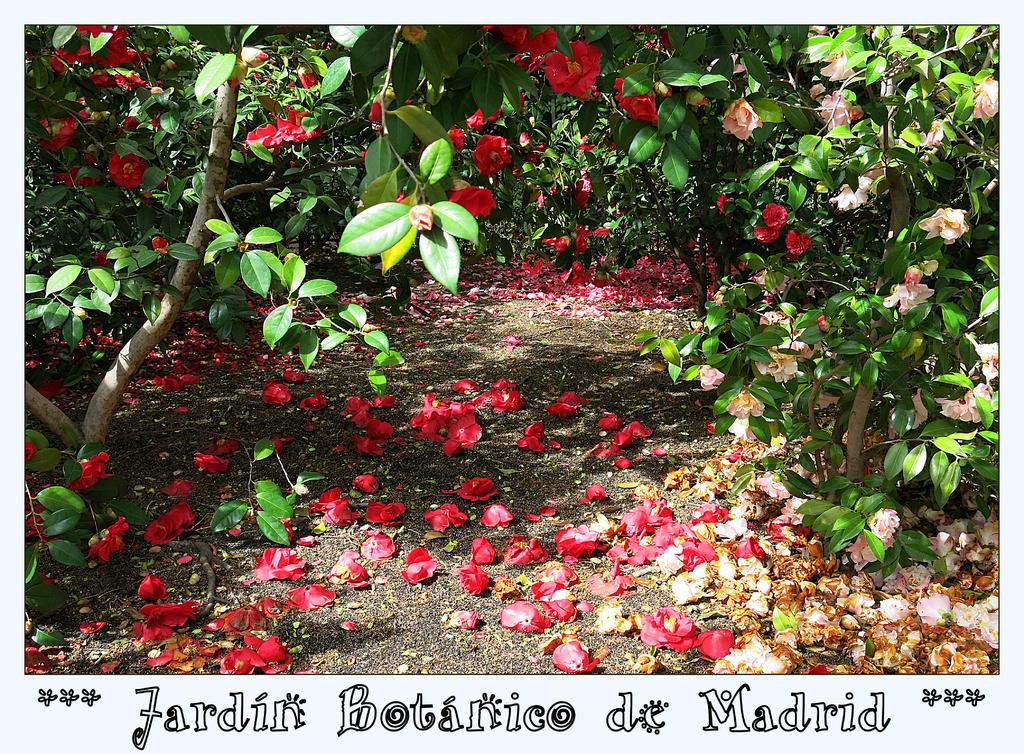What type of plants can be seen in the image? There are plants with flowers in the image. Are there any words or text present in the image? Yes, there are words on the image. What type of carriage is being used to transport the chess pieces in the image? There is no carriage or chess pieces present in the image; it features plants with flowers and words. 